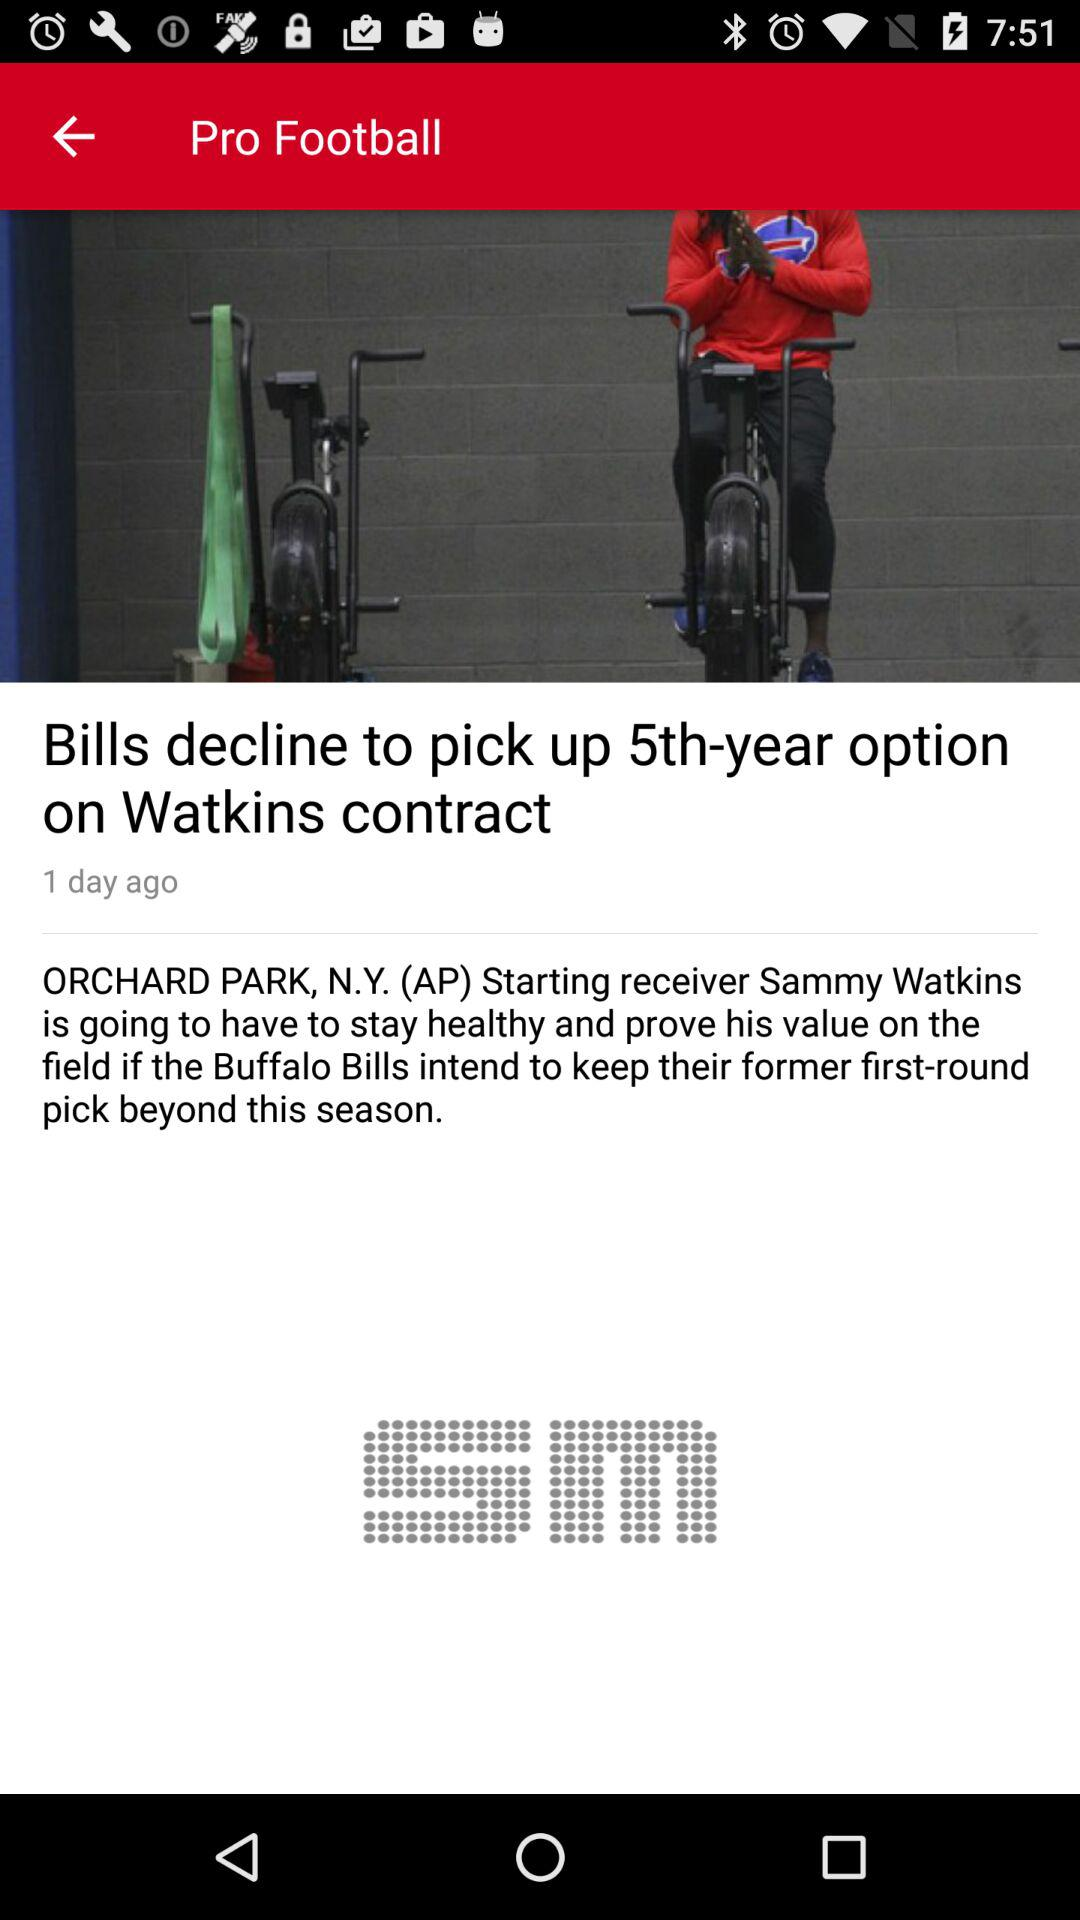What is the time of publication?
When the provided information is insufficient, respond with <no answer>. <no answer> 